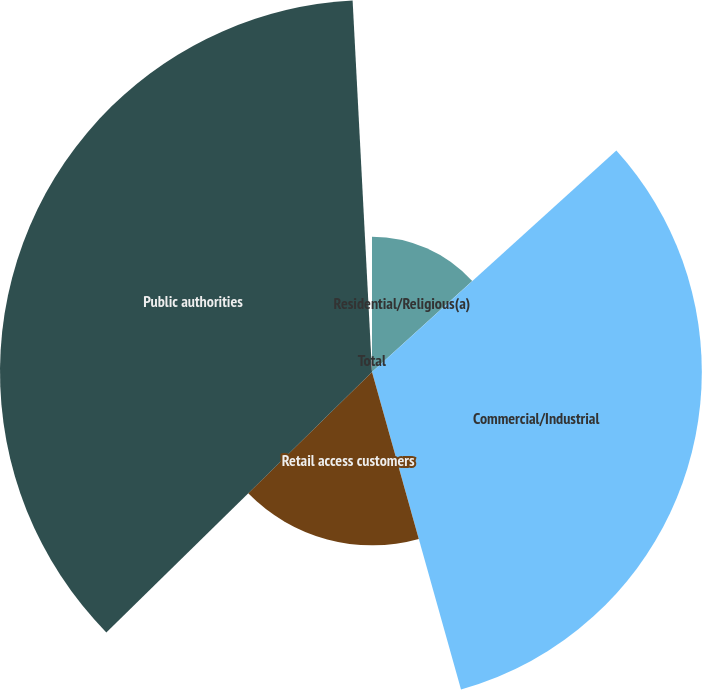<chart> <loc_0><loc_0><loc_500><loc_500><pie_chart><fcel>Residential/Religious(a)<fcel>Commercial/Industrial<fcel>Retail access customers<fcel>Public authorities<fcel>Total<nl><fcel>13.28%<fcel>32.37%<fcel>17.01%<fcel>36.51%<fcel>0.83%<nl></chart> 